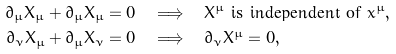Convert formula to latex. <formula><loc_0><loc_0><loc_500><loc_500>\partial _ { \mu } X _ { \mu } + \partial _ { \mu } X _ { \mu } = 0 & \quad \Longrightarrow \quad X ^ { \mu } \text { is independent of } x ^ { \mu } , \\ \partial _ { \nu } X _ { \mu } + \partial _ { \mu } X _ { \nu } = 0 & \quad \Longrightarrow \quad \partial _ { \nu } X ^ { \mu } = 0 ,</formula> 